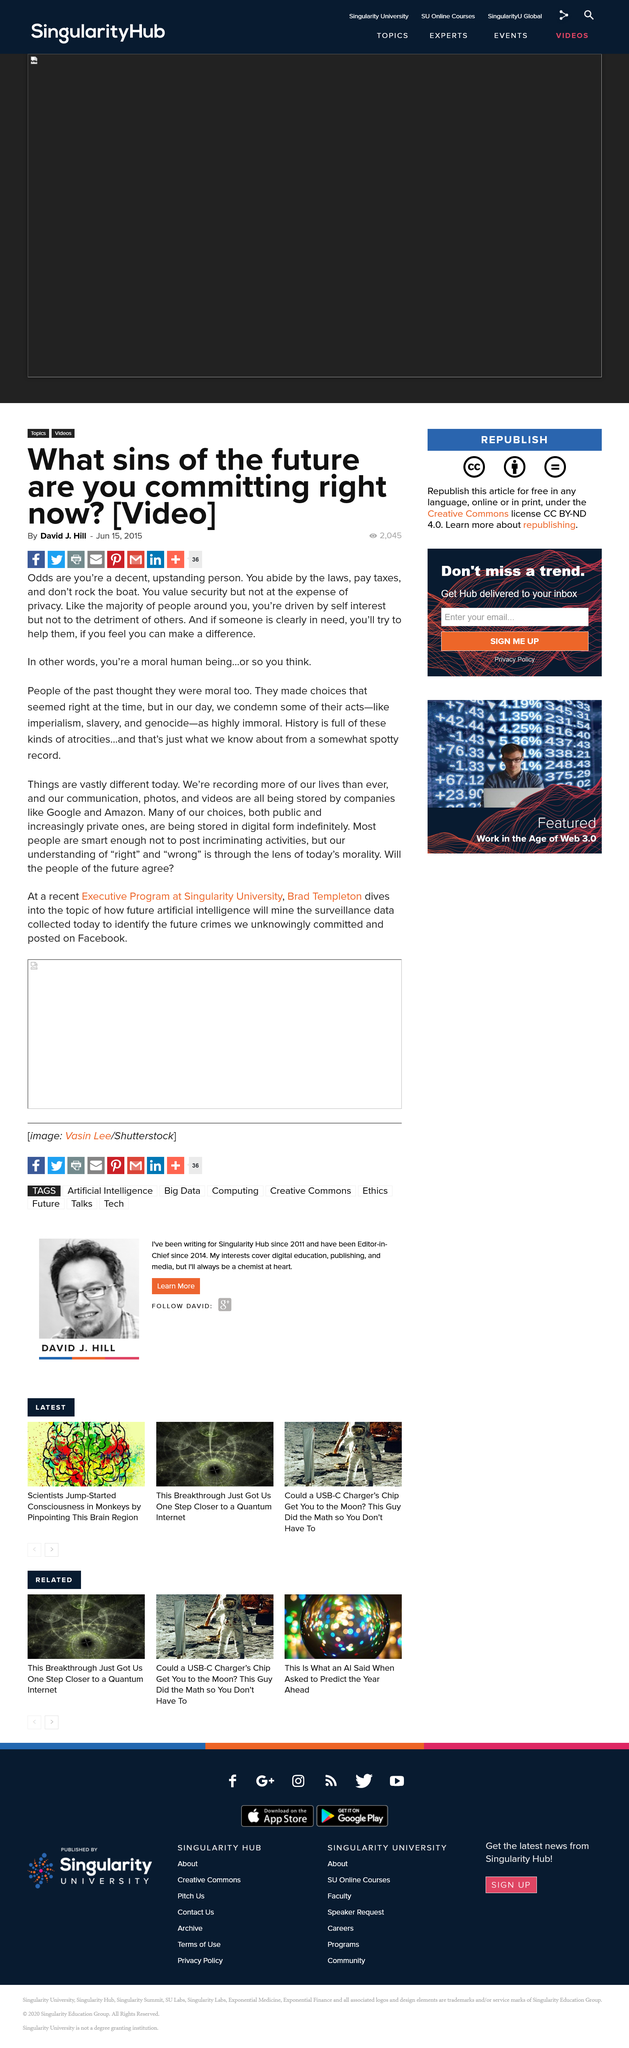Specify some key components in this picture. The first name of the author of the article is David. The article was written in 2015. In the past, people believed themselves to be moral. 